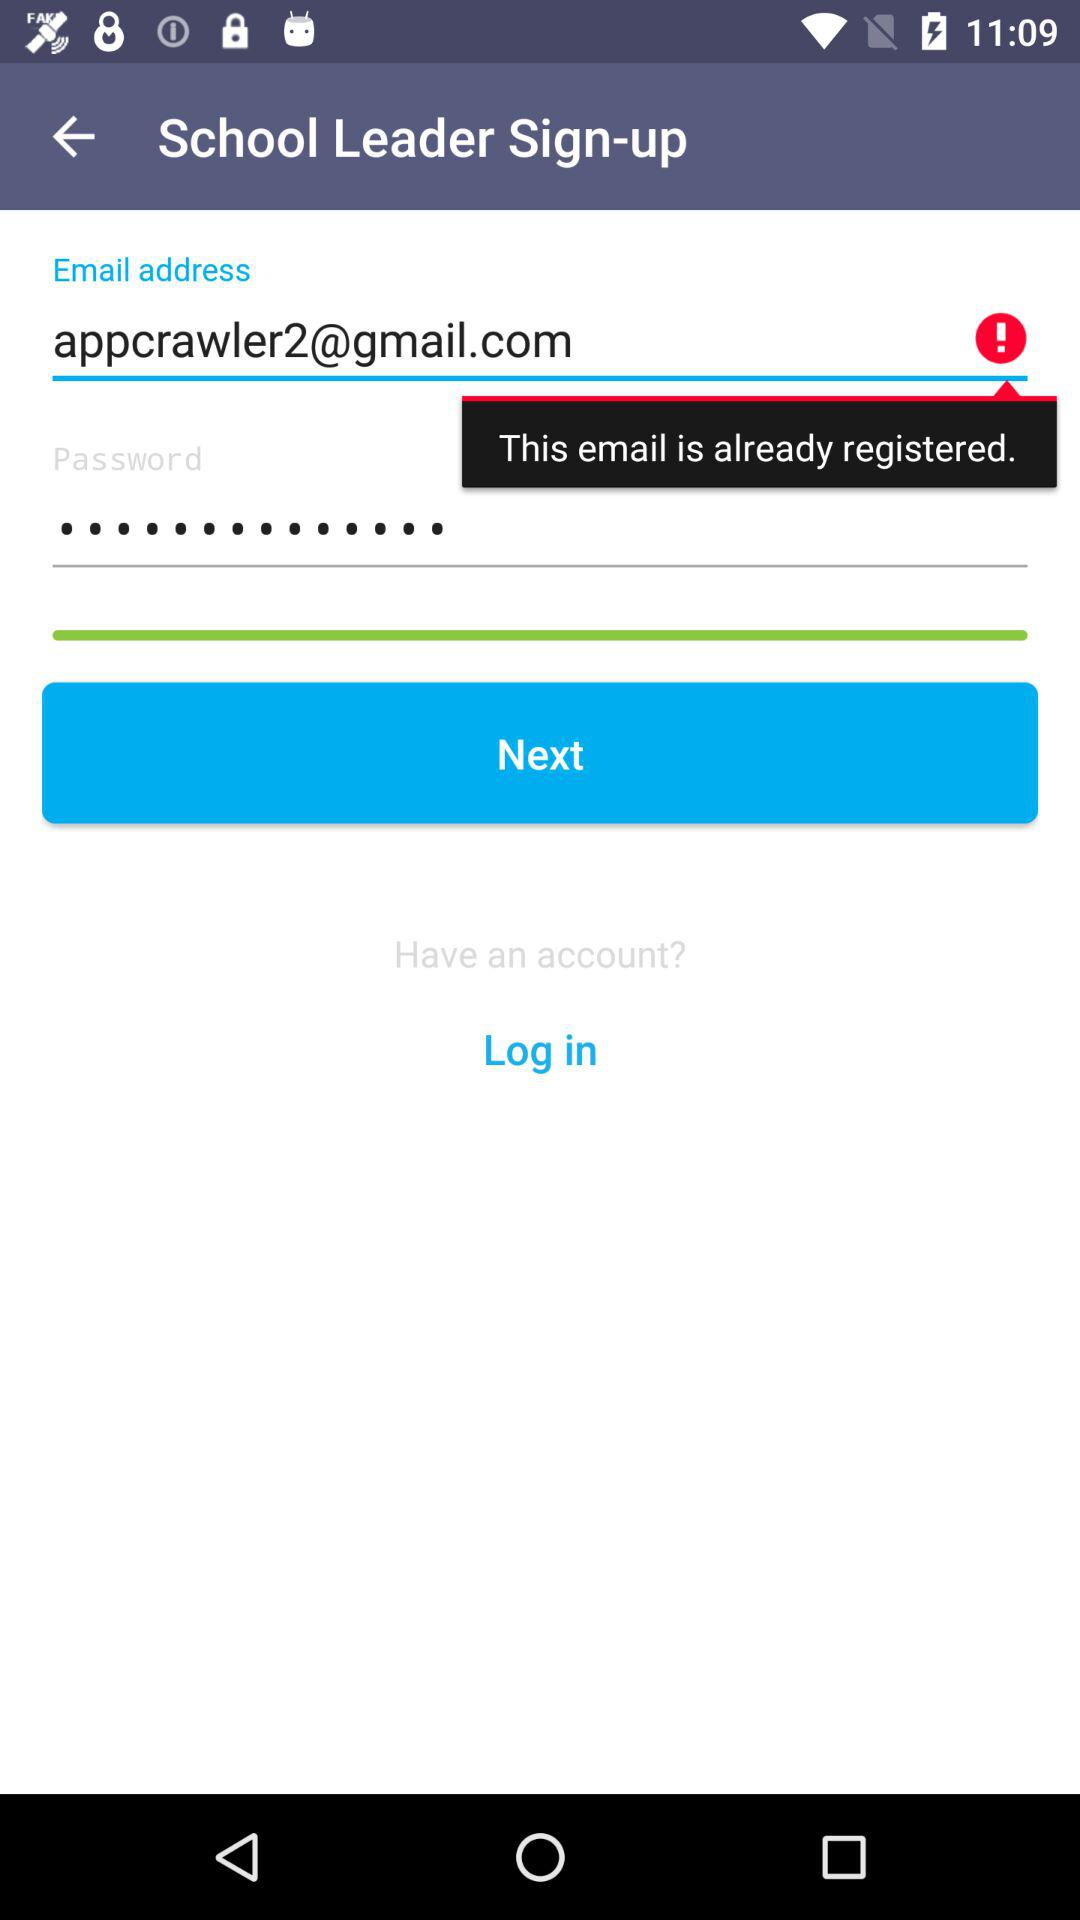What is the Gmail address? The Gmail address is appcrawler2@gmail.com. 